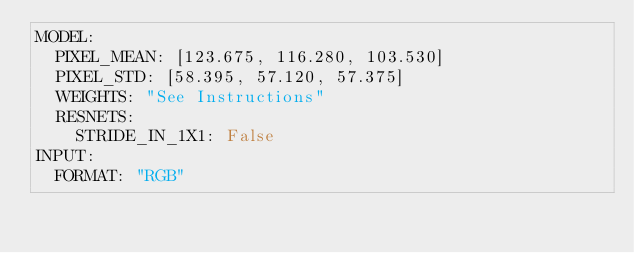<code> <loc_0><loc_0><loc_500><loc_500><_YAML_>MODEL:
  PIXEL_MEAN: [123.675, 116.280, 103.530]
  PIXEL_STD: [58.395, 57.120, 57.375]
  WEIGHTS: "See Instructions"
  RESNETS:
    STRIDE_IN_1X1: False
INPUT:
  FORMAT: "RGB"</code> 